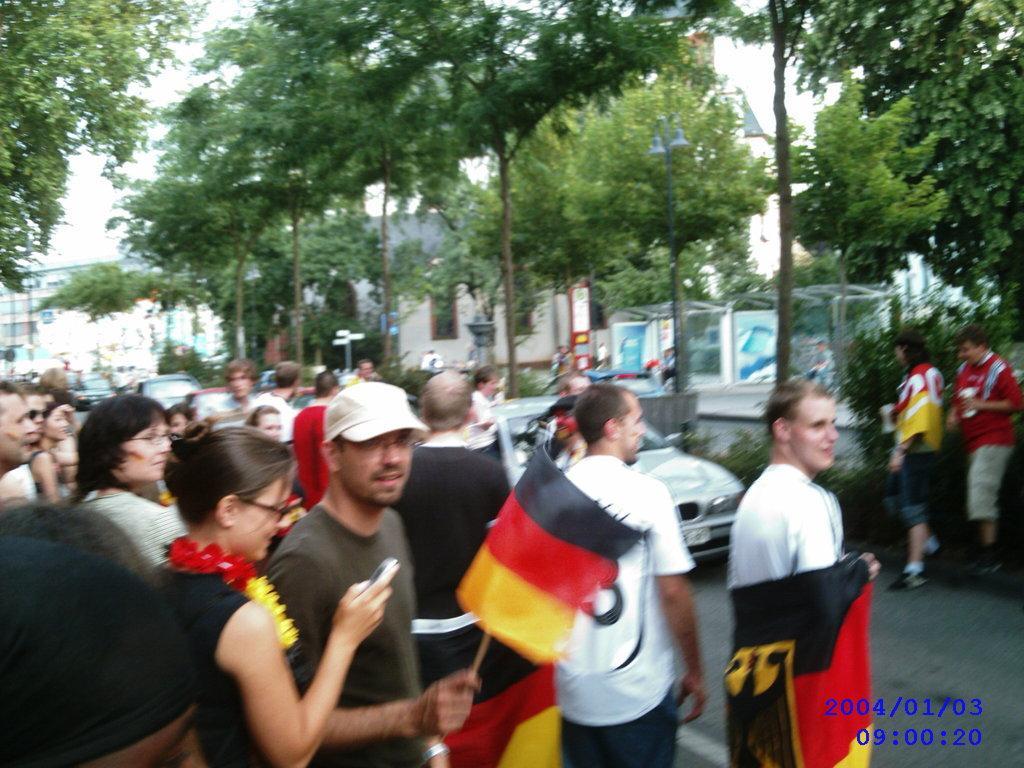Could you give a brief overview of what you see in this image? In this image we can see many people and few people holding some objects in their hands. There are many buildings in the image. There are many trees in the image. There are few vehicles in the image. We can see the sky in the image. 